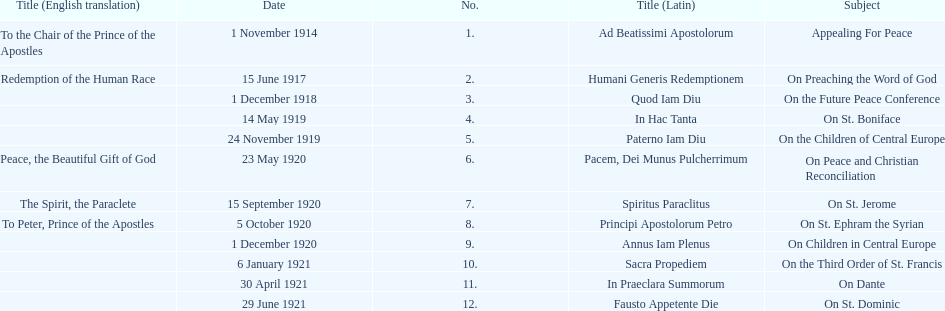What is the subject listed after appealing for peace? On Preaching the Word of God. 